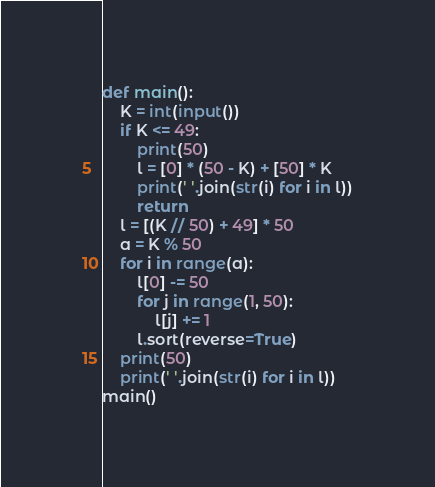Convert code to text. <code><loc_0><loc_0><loc_500><loc_500><_Python_>def main():
    K = int(input())
    if K <= 49:
        print(50)
        l = [0] * (50 - K) + [50] * K
        print(' '.join(str(i) for i in l))
        return
    l = [(K // 50) + 49] * 50
    a = K % 50
    for i in range(a):
        l[0] -= 50
        for j in range(1, 50):
            l[j] += 1
        l.sort(reverse=True)
    print(50)
    print(' '.join(str(i) for i in l))
main()
</code> 